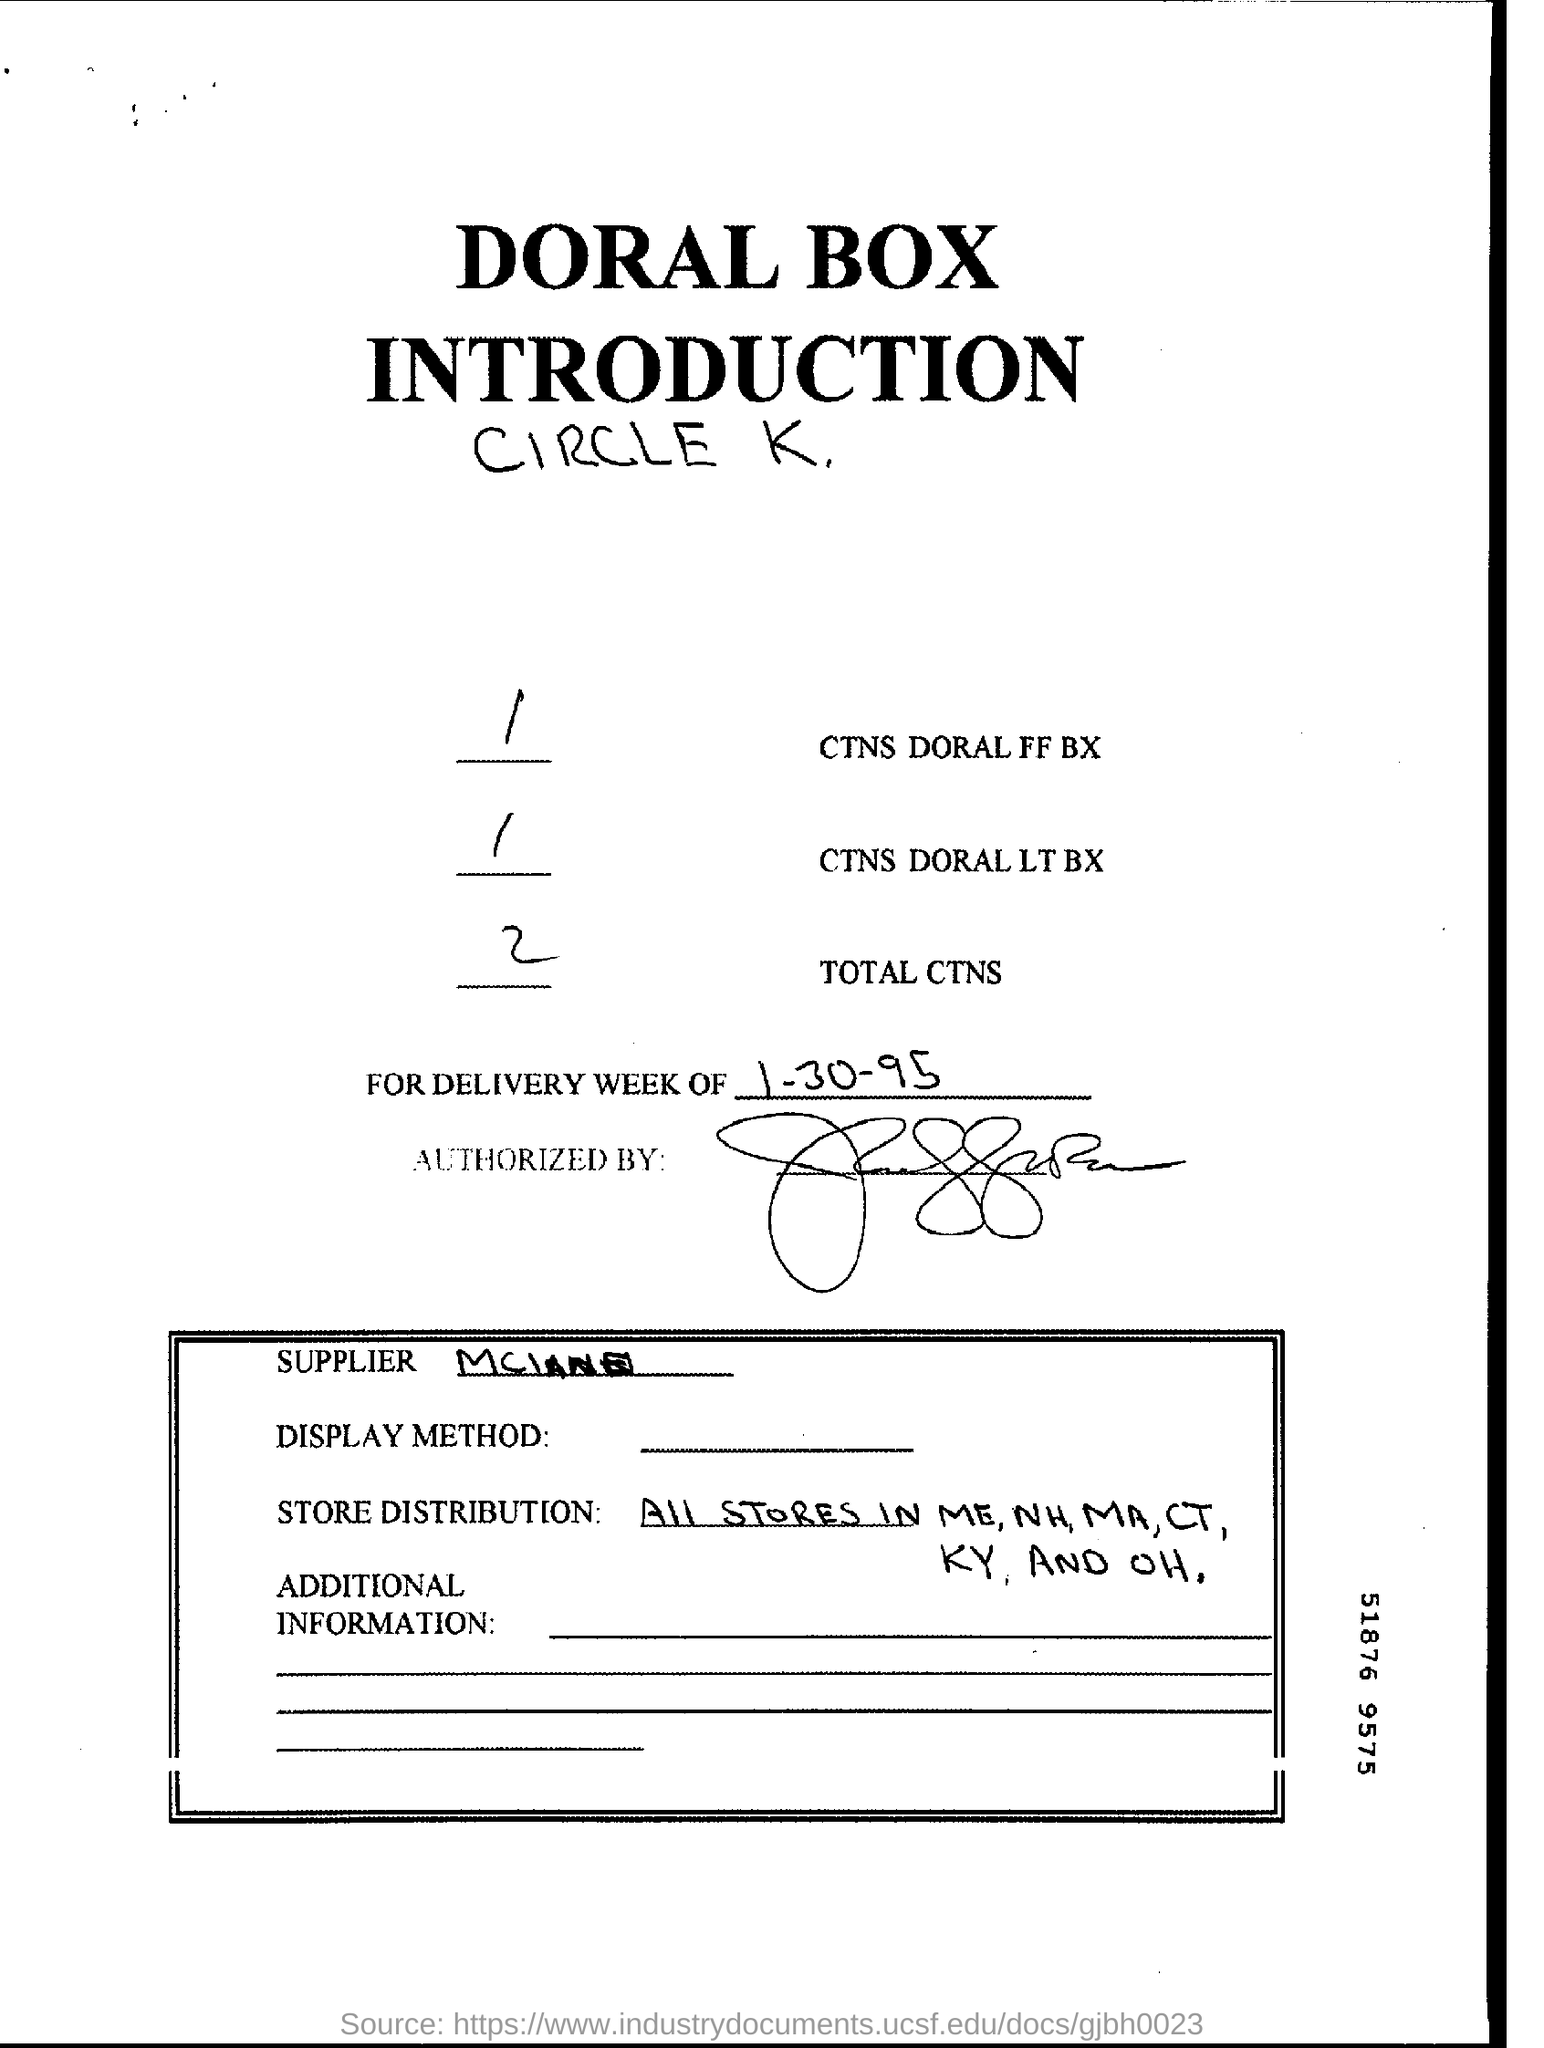What is written in the Letter Head ?
Ensure brevity in your answer.  DORAL BOX INTRODUCTION. What is written in the Total CTNS Field ?
Make the answer very short. 2. What is the Date mentioned in the document ?
Make the answer very short. 1-30-95. 